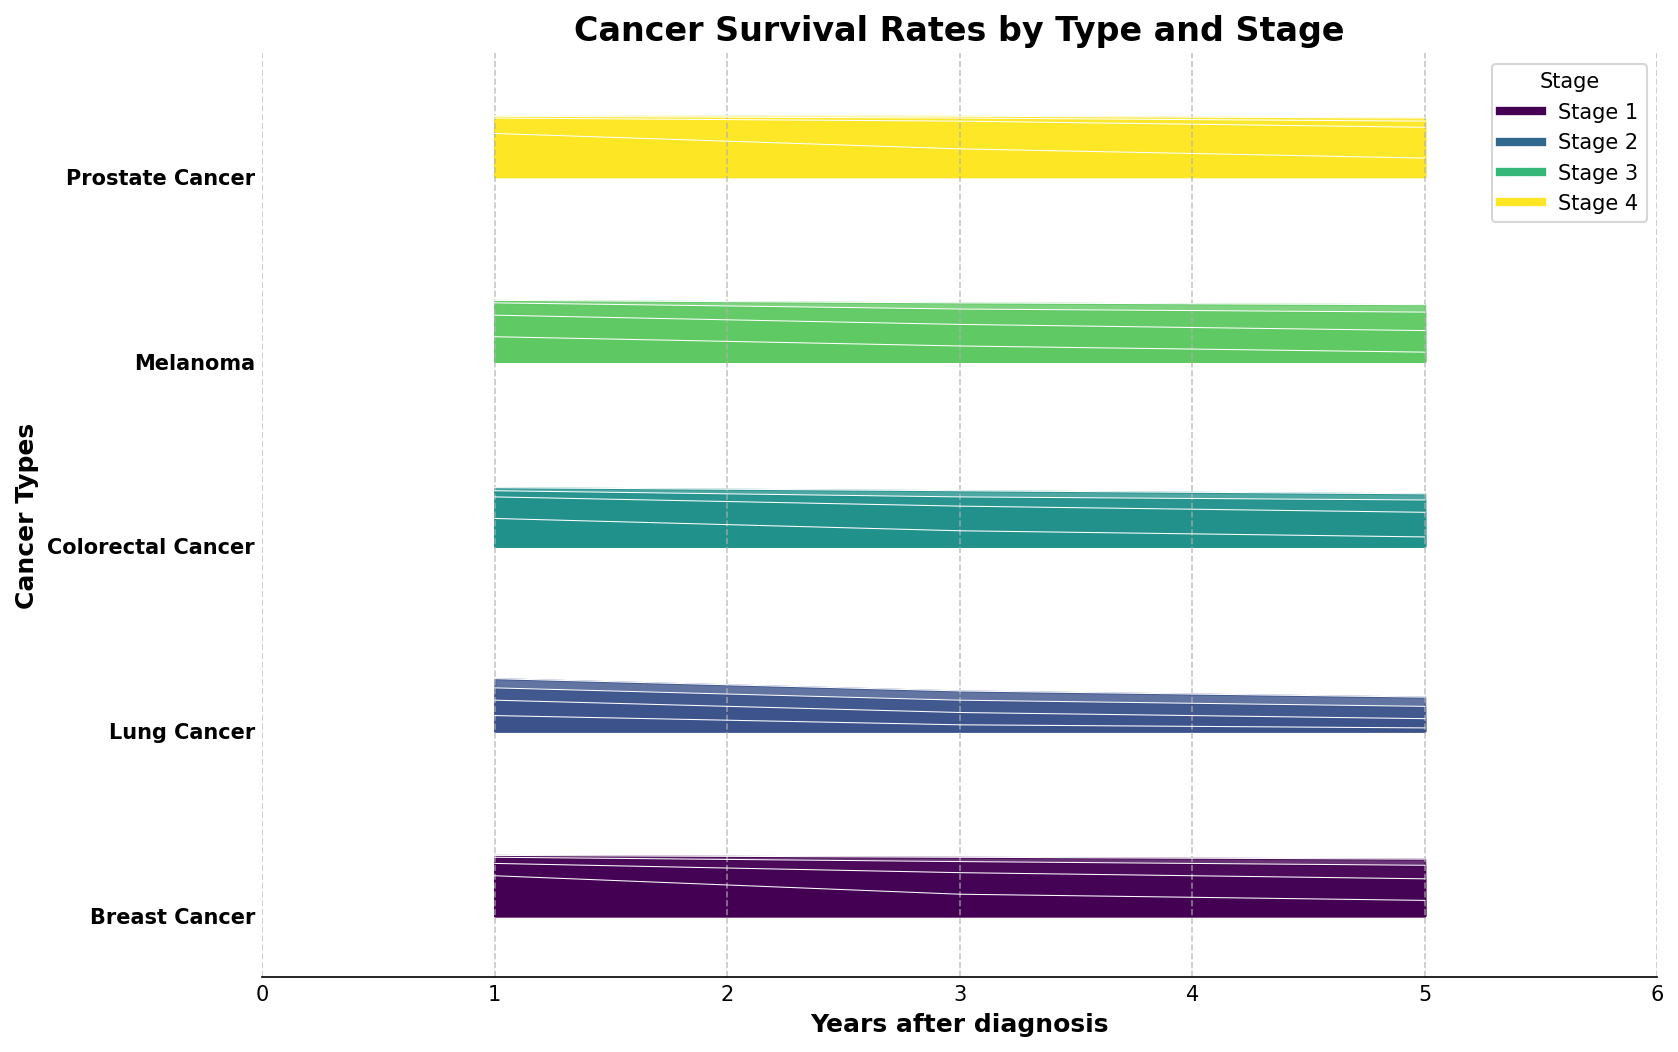How many different types of cancer are shown in the figure? The Y-axis shows the different types of cancer, and there are individual labels for each type. By counting these labels, we can determine the number of cancer types in the figure.
Answer: 5 What is the 1-year survival rate for Lung Cancer at Stage II? Locate Lung Cancer on the Y-axis, then find the curve corresponding to Stage II. Look at the height of the curve at the 1-year mark to determine the survival rate.
Answer: 70 Which cancer type has the highest 5-year survival rate at Stage I? Compare the peaks of the curves at the 5-year mark for each cancer type at Stage I. The curve with the highest peak represents the highest 5-year survival rate.
Answer: Prostate Cancer How does the 3-year survival rate for Breast Cancer at Stage IV compare to Colorectal Cancer at Stage III? Locate the curves for Breast Cancer at Stage IV and Colorectal Cancer at Stage III on the Y-axis, then compare their heights at the 3-year mark.
Answer: Lower In which stage of Lung Cancer does the survival rate drop most drastically from 1 year to 5 years? For each stage of Lung Cancer, determine the survival rates at 1 year and 5 years, then calculate the difference. The stage with the highest difference shows the most drastic drop.
Answer: Stage IV What's the average 1-year survival rate across all cancers at Stage I? Sum the 1-year survival rates for Stage I of all cancers and divide by the number of cancers. This involves summing up 98, 85, 95, 99, and 99, then dividing by 5.
Answer: 95.2 What's the difference in the 5-year survival rate between Melanoma at Stage II and Stage IV? Find the 5-year survival rates for Melanoma at Stage II and Stage IV, then subtract the Stage IV rate from the Stage II rate.
Answer: 65 Which cancer type shows the smallest decline in survival rate from 1 year to 5 years for Stage II? For each cancer type at Stage II, calculate the difference between the 1-year and 5-year survival rates. The smallest difference indicates the smallest decline.
Answer: Prostate Cancer What is the title of the figure? The title of the figure is displayed at the top of the plot, providing a summary of the content depicted.
Answer: Cancer Survival Rates by Type and Stage How does the 3-year survival rate for Breast Cancer at Stage III compare to Prostate Cancer at Stage IV? Locate the curves for Breast Cancer at Stage III and Prostate Cancer at Stage IV, then compare their heights at the 3-year mark.
Answer: Higher 